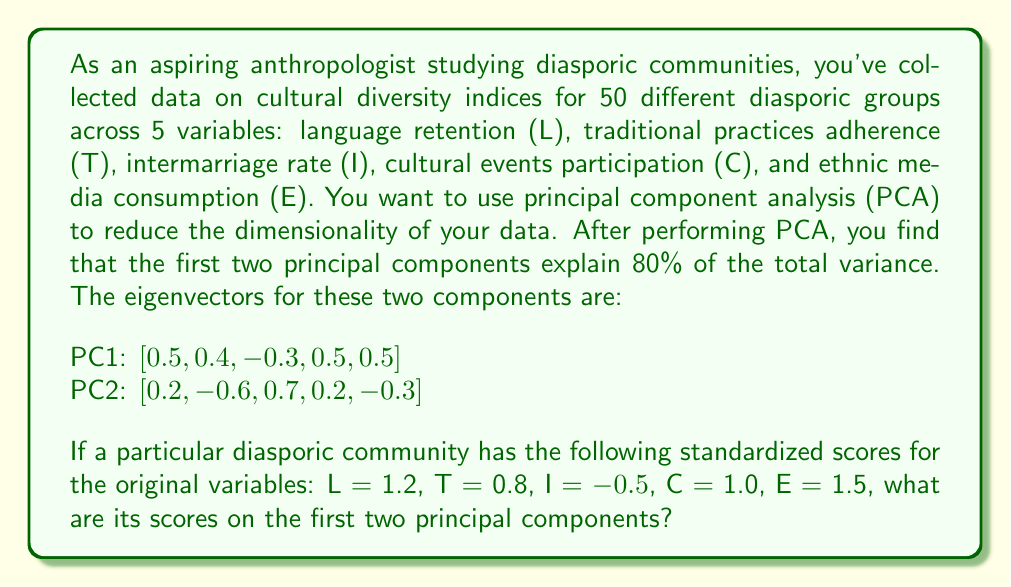Could you help me with this problem? To solve this problem, we need to follow these steps:

1) Recall that the score on a principal component is calculated by taking the dot product of the standardized data vector and the eigenvector for that component.

2) Let's define our data vector:
   $\mathbf{x} = [1.2, 0.8, -0.5, 1.0, 1.5]$

3) For PC1:
   $\mathbf{v_1} = [0.5, 0.4, -0.3, 0.5, 0.5]$
   
   Score on PC1 = $\mathbf{x} \cdot \mathbf{v_1}$
   
   $= (1.2 \times 0.5) + (0.8 \times 0.4) + (-0.5 \times -0.3) + (1.0 \times 0.5) + (1.5 \times 0.5)$
   
   $= 0.6 + 0.32 + 0.15 + 0.5 + 0.75$
   
   $= 2.32$

4) For PC2:
   $\mathbf{v_2} = [0.2, -0.6, 0.7, 0.2, -0.3]$
   
   Score on PC2 = $\mathbf{x} \cdot \mathbf{v_2}$
   
   $= (1.2 \times 0.2) + (0.8 \times -0.6) + (-0.5 \times 0.7) + (1.0 \times 0.2) + (1.5 \times -0.3)$
   
   $= 0.24 - 0.48 - 0.35 + 0.2 - 0.45$
   
   $= -0.84$

Therefore, the scores on the first two principal components are 2.32 and -0.84 respectively.
Answer: The scores on the first two principal components are:
PC1: 2.32
PC2: -0.84 